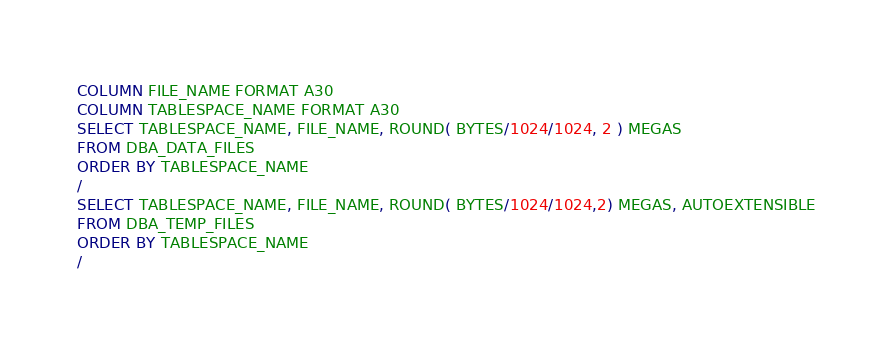Convert code to text. <code><loc_0><loc_0><loc_500><loc_500><_SQL_>COLUMN FILE_NAME FORMAT A30
COLUMN TABLESPACE_NAME FORMAT A30
SELECT TABLESPACE_NAME, FILE_NAME, ROUND( BYTES/1024/1024, 2 ) MEGAS
FROM DBA_DATA_FILES
ORDER BY TABLESPACE_NAME
/
SELECT TABLESPACE_NAME, FILE_NAME, ROUND( BYTES/1024/1024,2) MEGAS, AUTOEXTENSIBLE
FROM DBA_TEMP_FILES
ORDER BY TABLESPACE_NAME
/</code> 